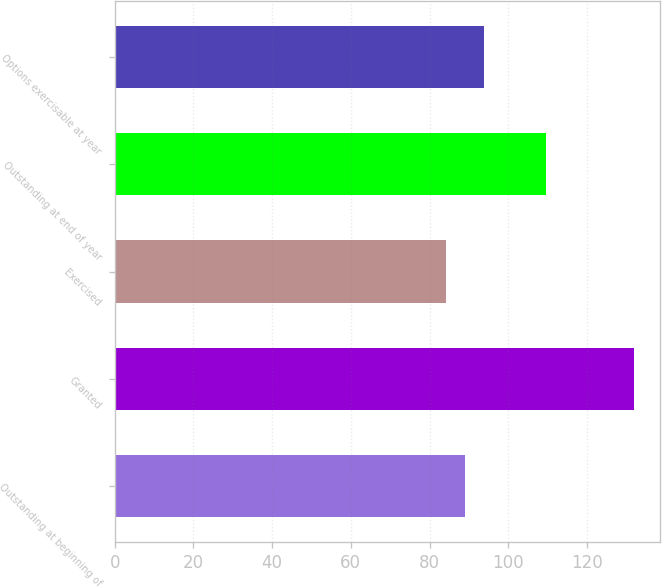Convert chart to OTSL. <chart><loc_0><loc_0><loc_500><loc_500><bar_chart><fcel>Outstanding at beginning of<fcel>Granted<fcel>Exercised<fcel>Outstanding at end of year<fcel>Options exercisable at year<nl><fcel>89<fcel>131.87<fcel>84.24<fcel>109.71<fcel>93.76<nl></chart> 